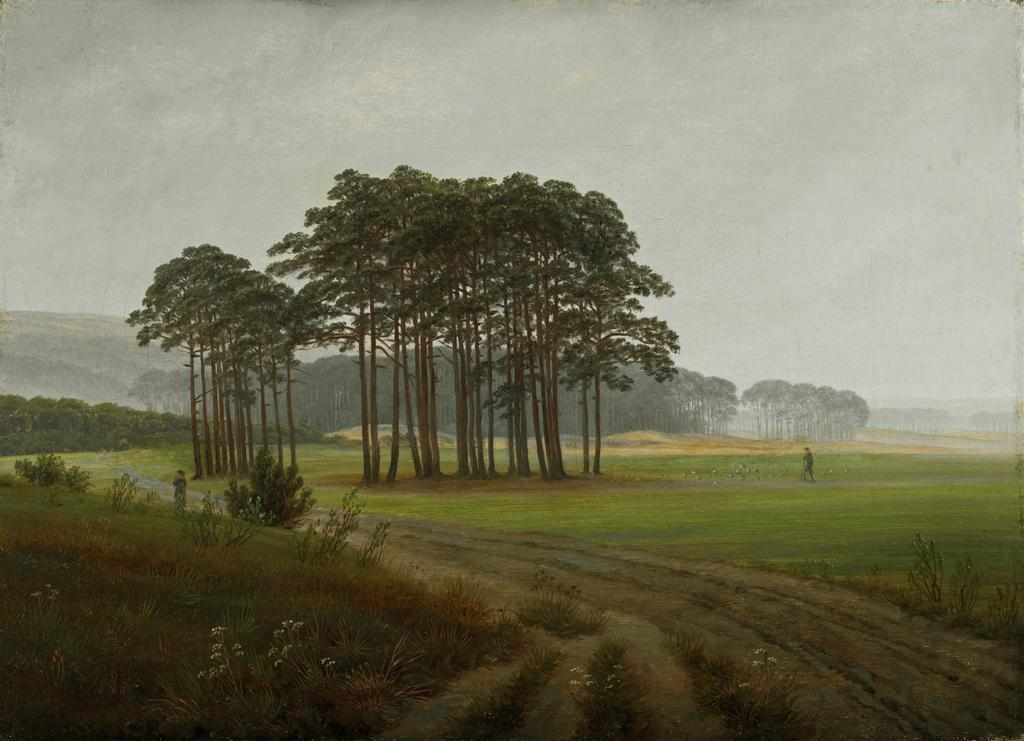What type of vegetation is present in the image? There is grass and small plants in the image. What are the people in the image doing? People are walking on the road in the image. What other natural elements can be seen in the image? There are trees in the image. What is visible in the background of the image? There are hills and the sky in the background of the image. What type of summer connection can be seen in the image? There is no reference to summer or a connection in the image; it features grass, small plants, people walking on the road, trees, hills, and the sky. 